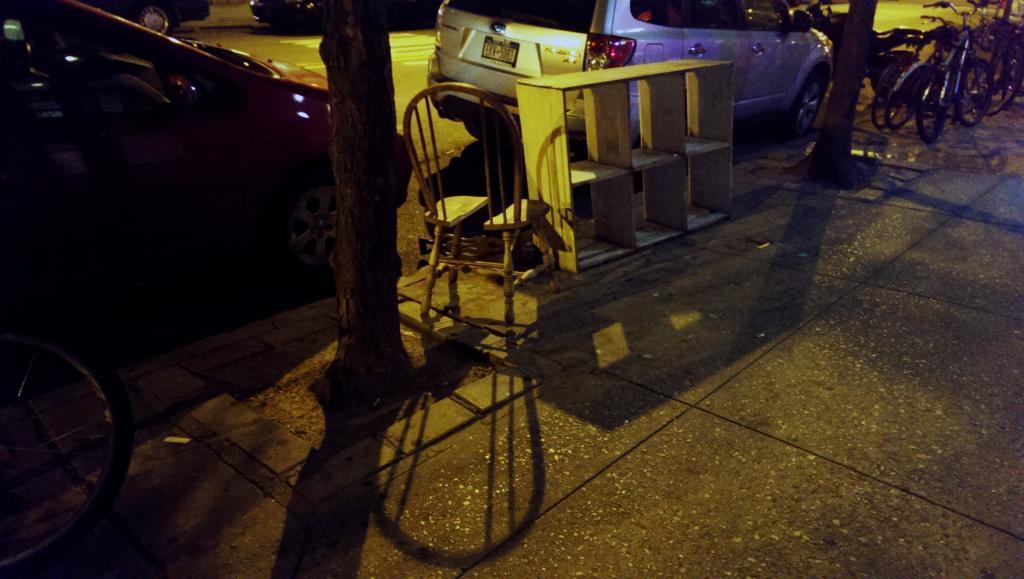Describe this image in one or two sentences. In this image, we can see vehicles on the road and there is a chair and we can see a stand and there are tree trunks and bicycles. 